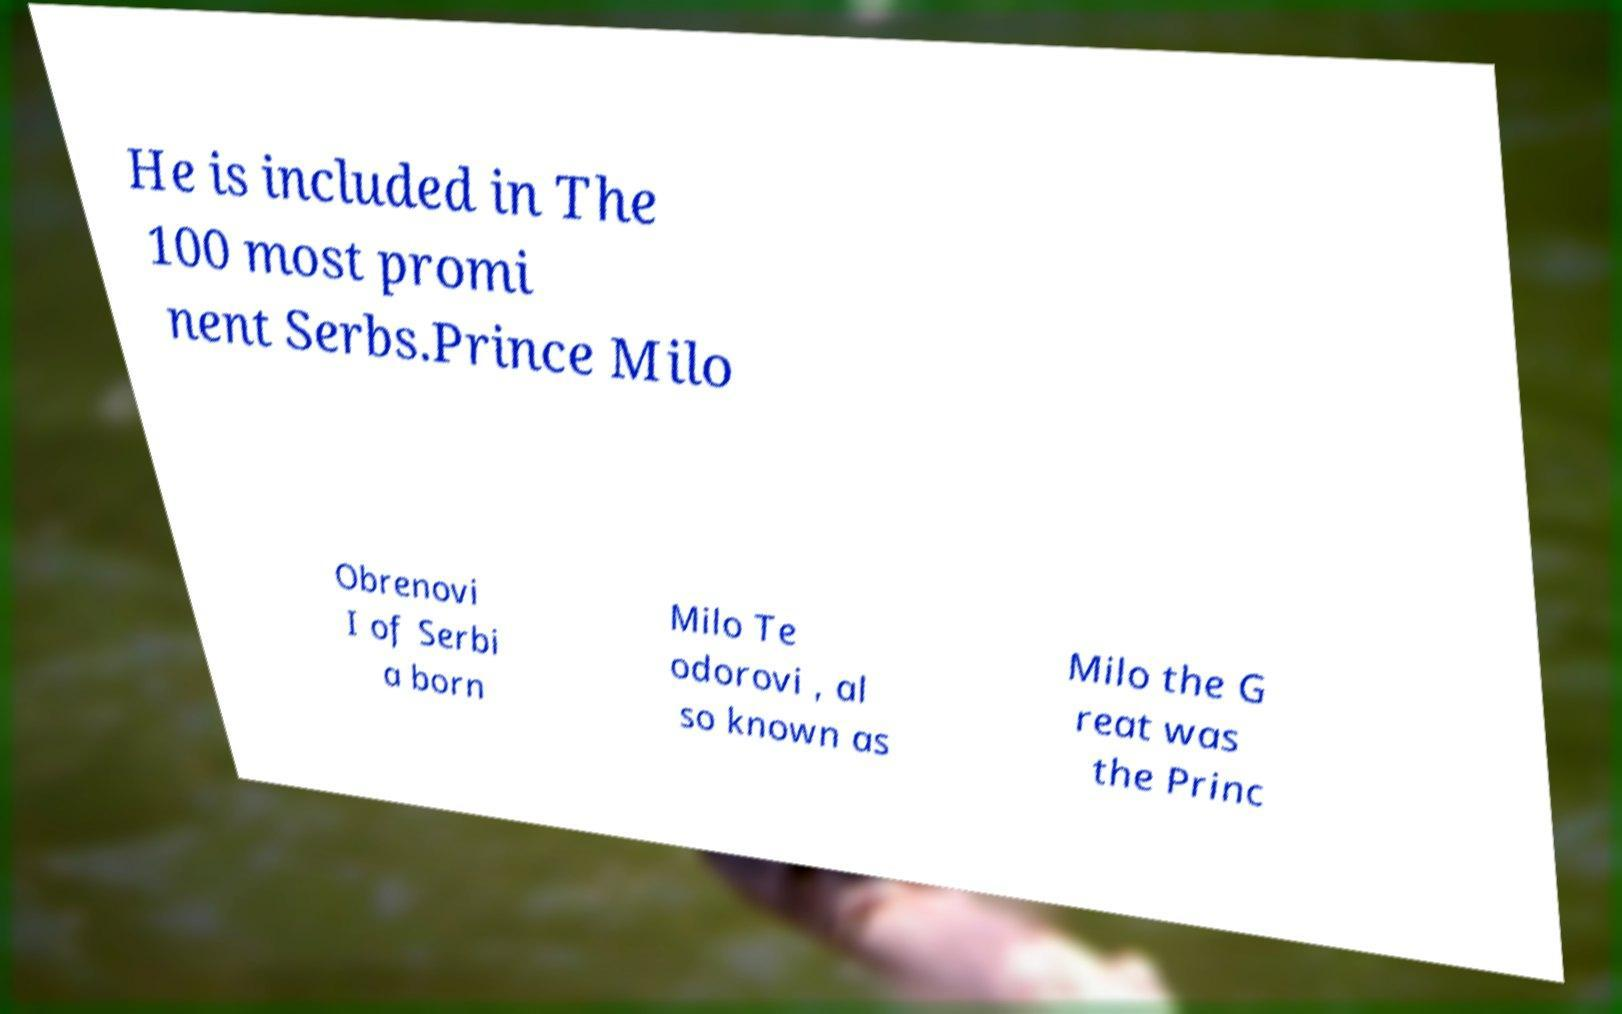Please identify and transcribe the text found in this image. He is included in The 100 most promi nent Serbs.Prince Milo Obrenovi I of Serbi a born Milo Te odorovi , al so known as Milo the G reat was the Princ 